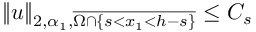Convert formula to latex. <formula><loc_0><loc_0><loc_500><loc_500>\| u \| _ { 2 , \alpha _ { 1 } , \overline { { \Omega \cap \{ s < x _ { 1 } < h - s \} } } } \leq C _ { s }</formula> 